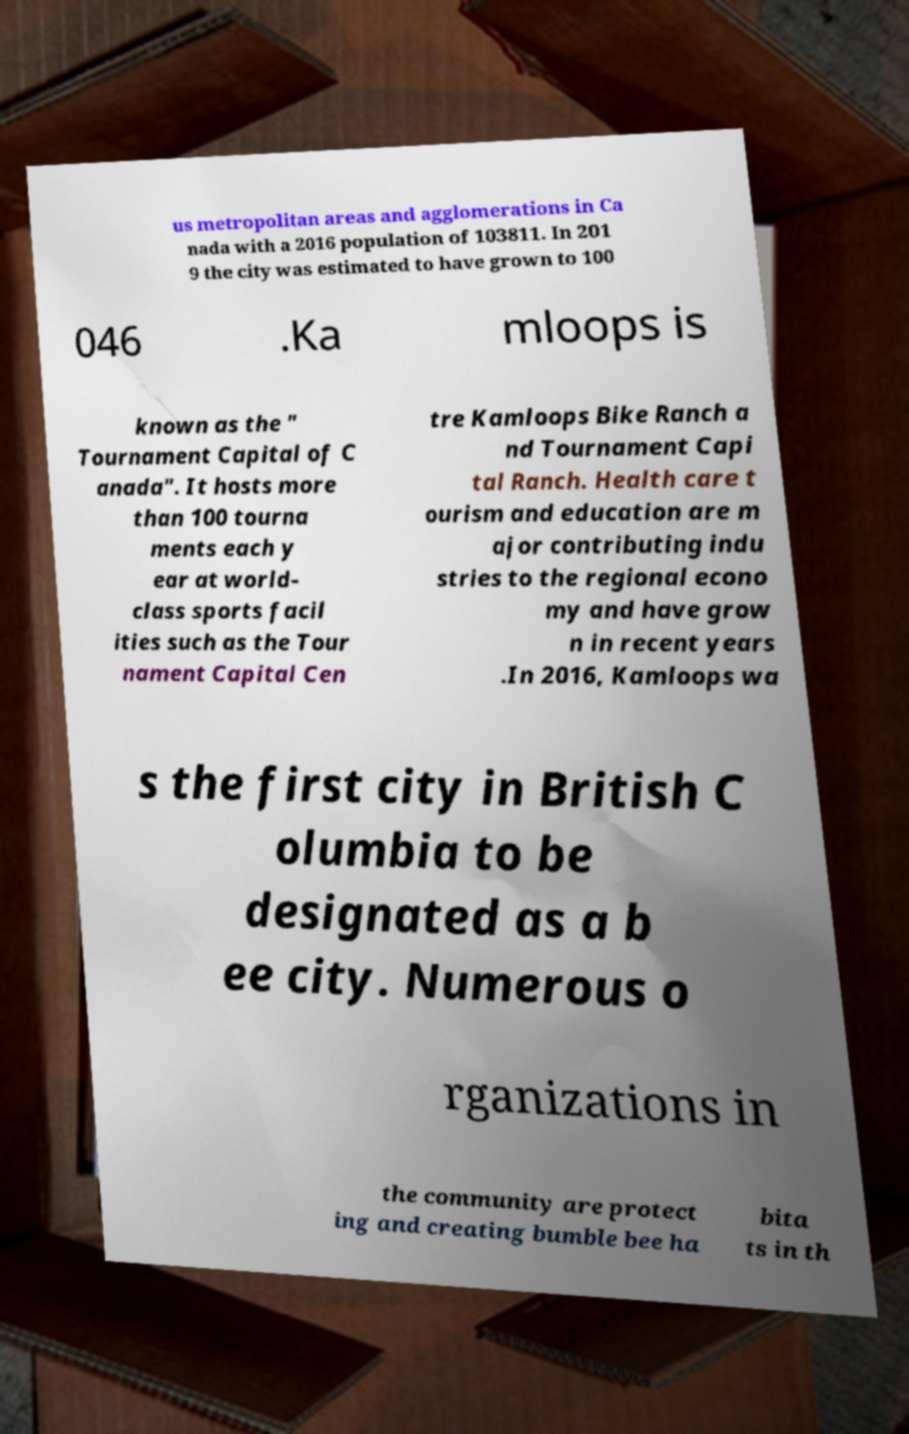Can you read and provide the text displayed in the image?This photo seems to have some interesting text. Can you extract and type it out for me? us metropolitan areas and agglomerations in Ca nada with a 2016 population of 103811. In 201 9 the city was estimated to have grown to 100 046 .Ka mloops is known as the " Tournament Capital of C anada". It hosts more than 100 tourna ments each y ear at world- class sports facil ities such as the Tour nament Capital Cen tre Kamloops Bike Ranch a nd Tournament Capi tal Ranch. Health care t ourism and education are m ajor contributing indu stries to the regional econo my and have grow n in recent years .In 2016, Kamloops wa s the first city in British C olumbia to be designated as a b ee city. Numerous o rganizations in the community are protect ing and creating bumble bee ha bita ts in th 